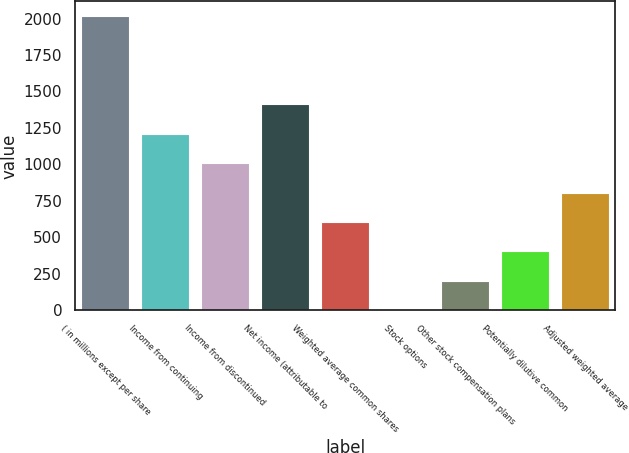<chart> <loc_0><loc_0><loc_500><loc_500><bar_chart><fcel>( in millions except per share<fcel>Income from continuing<fcel>Income from discontinued<fcel>Net income (attributable to<fcel>Weighted average common shares<fcel>Stock options<fcel>Other stock compensation plans<fcel>Potentially dilutive common<fcel>Adjusted weighted average<nl><fcel>2016<fcel>1209.92<fcel>1008.4<fcel>1411.44<fcel>605.36<fcel>0.8<fcel>202.32<fcel>403.84<fcel>806.88<nl></chart> 